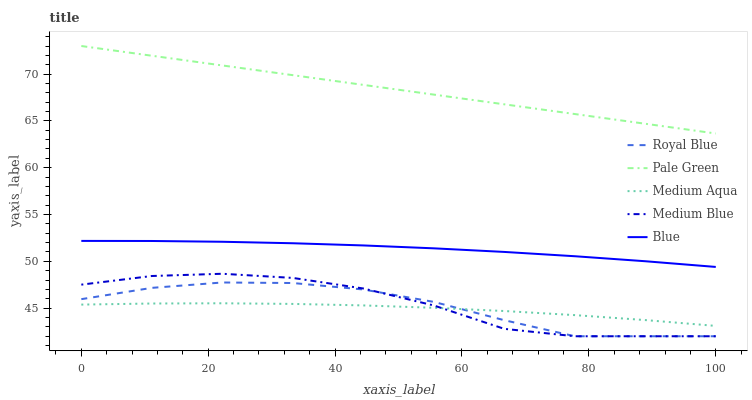Does Medium Aqua have the minimum area under the curve?
Answer yes or no. Yes. Does Pale Green have the maximum area under the curve?
Answer yes or no. Yes. Does Royal Blue have the minimum area under the curve?
Answer yes or no. No. Does Royal Blue have the maximum area under the curve?
Answer yes or no. No. Is Pale Green the smoothest?
Answer yes or no. Yes. Is Medium Blue the roughest?
Answer yes or no. Yes. Is Royal Blue the smoothest?
Answer yes or no. No. Is Royal Blue the roughest?
Answer yes or no. No. Does Royal Blue have the lowest value?
Answer yes or no. Yes. Does Pale Green have the lowest value?
Answer yes or no. No. Does Pale Green have the highest value?
Answer yes or no. Yes. Does Royal Blue have the highest value?
Answer yes or no. No. Is Medium Aqua less than Blue?
Answer yes or no. Yes. Is Pale Green greater than Blue?
Answer yes or no. Yes. Does Royal Blue intersect Medium Blue?
Answer yes or no. Yes. Is Royal Blue less than Medium Blue?
Answer yes or no. No. Is Royal Blue greater than Medium Blue?
Answer yes or no. No. Does Medium Aqua intersect Blue?
Answer yes or no. No. 